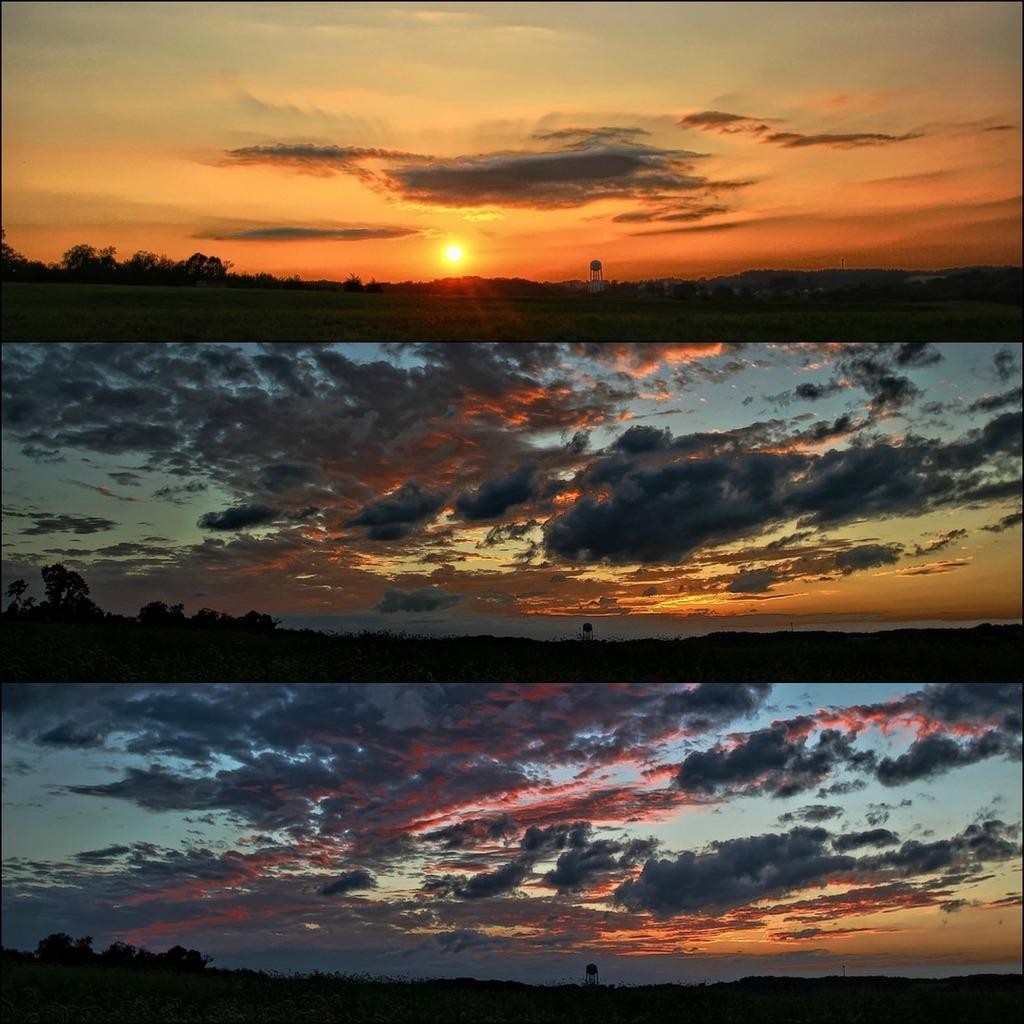Describe this image in one or two sentences. There are three pictures where the above picture has the sun and trees in the background and the ground is greenery and the below two pictures has trees and a cloudy sky. 